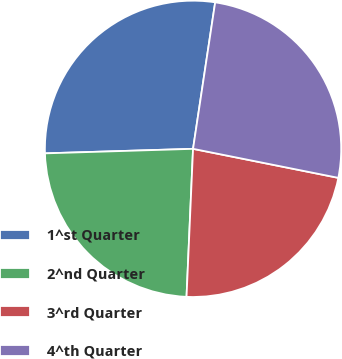<chart> <loc_0><loc_0><loc_500><loc_500><pie_chart><fcel>1^st Quarter<fcel>2^nd Quarter<fcel>3^rd Quarter<fcel>4^th Quarter<nl><fcel>27.87%<fcel>23.81%<fcel>22.56%<fcel>25.75%<nl></chart> 